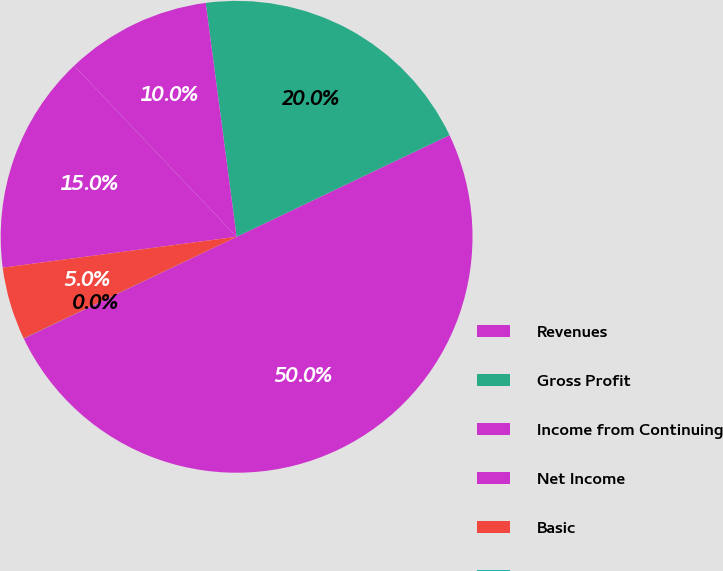Convert chart. <chart><loc_0><loc_0><loc_500><loc_500><pie_chart><fcel>Revenues<fcel>Gross Profit<fcel>Income from Continuing<fcel>Net Income<fcel>Basic<fcel>Diluted<nl><fcel>49.99%<fcel>20.0%<fcel>10.0%<fcel>15.0%<fcel>5.0%<fcel>0.01%<nl></chart> 